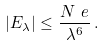Convert formula to latex. <formula><loc_0><loc_0><loc_500><loc_500>| E _ { \lambda } | \leq \frac { N ^ { \ } e } { \lambda ^ { 6 } } \, .</formula> 